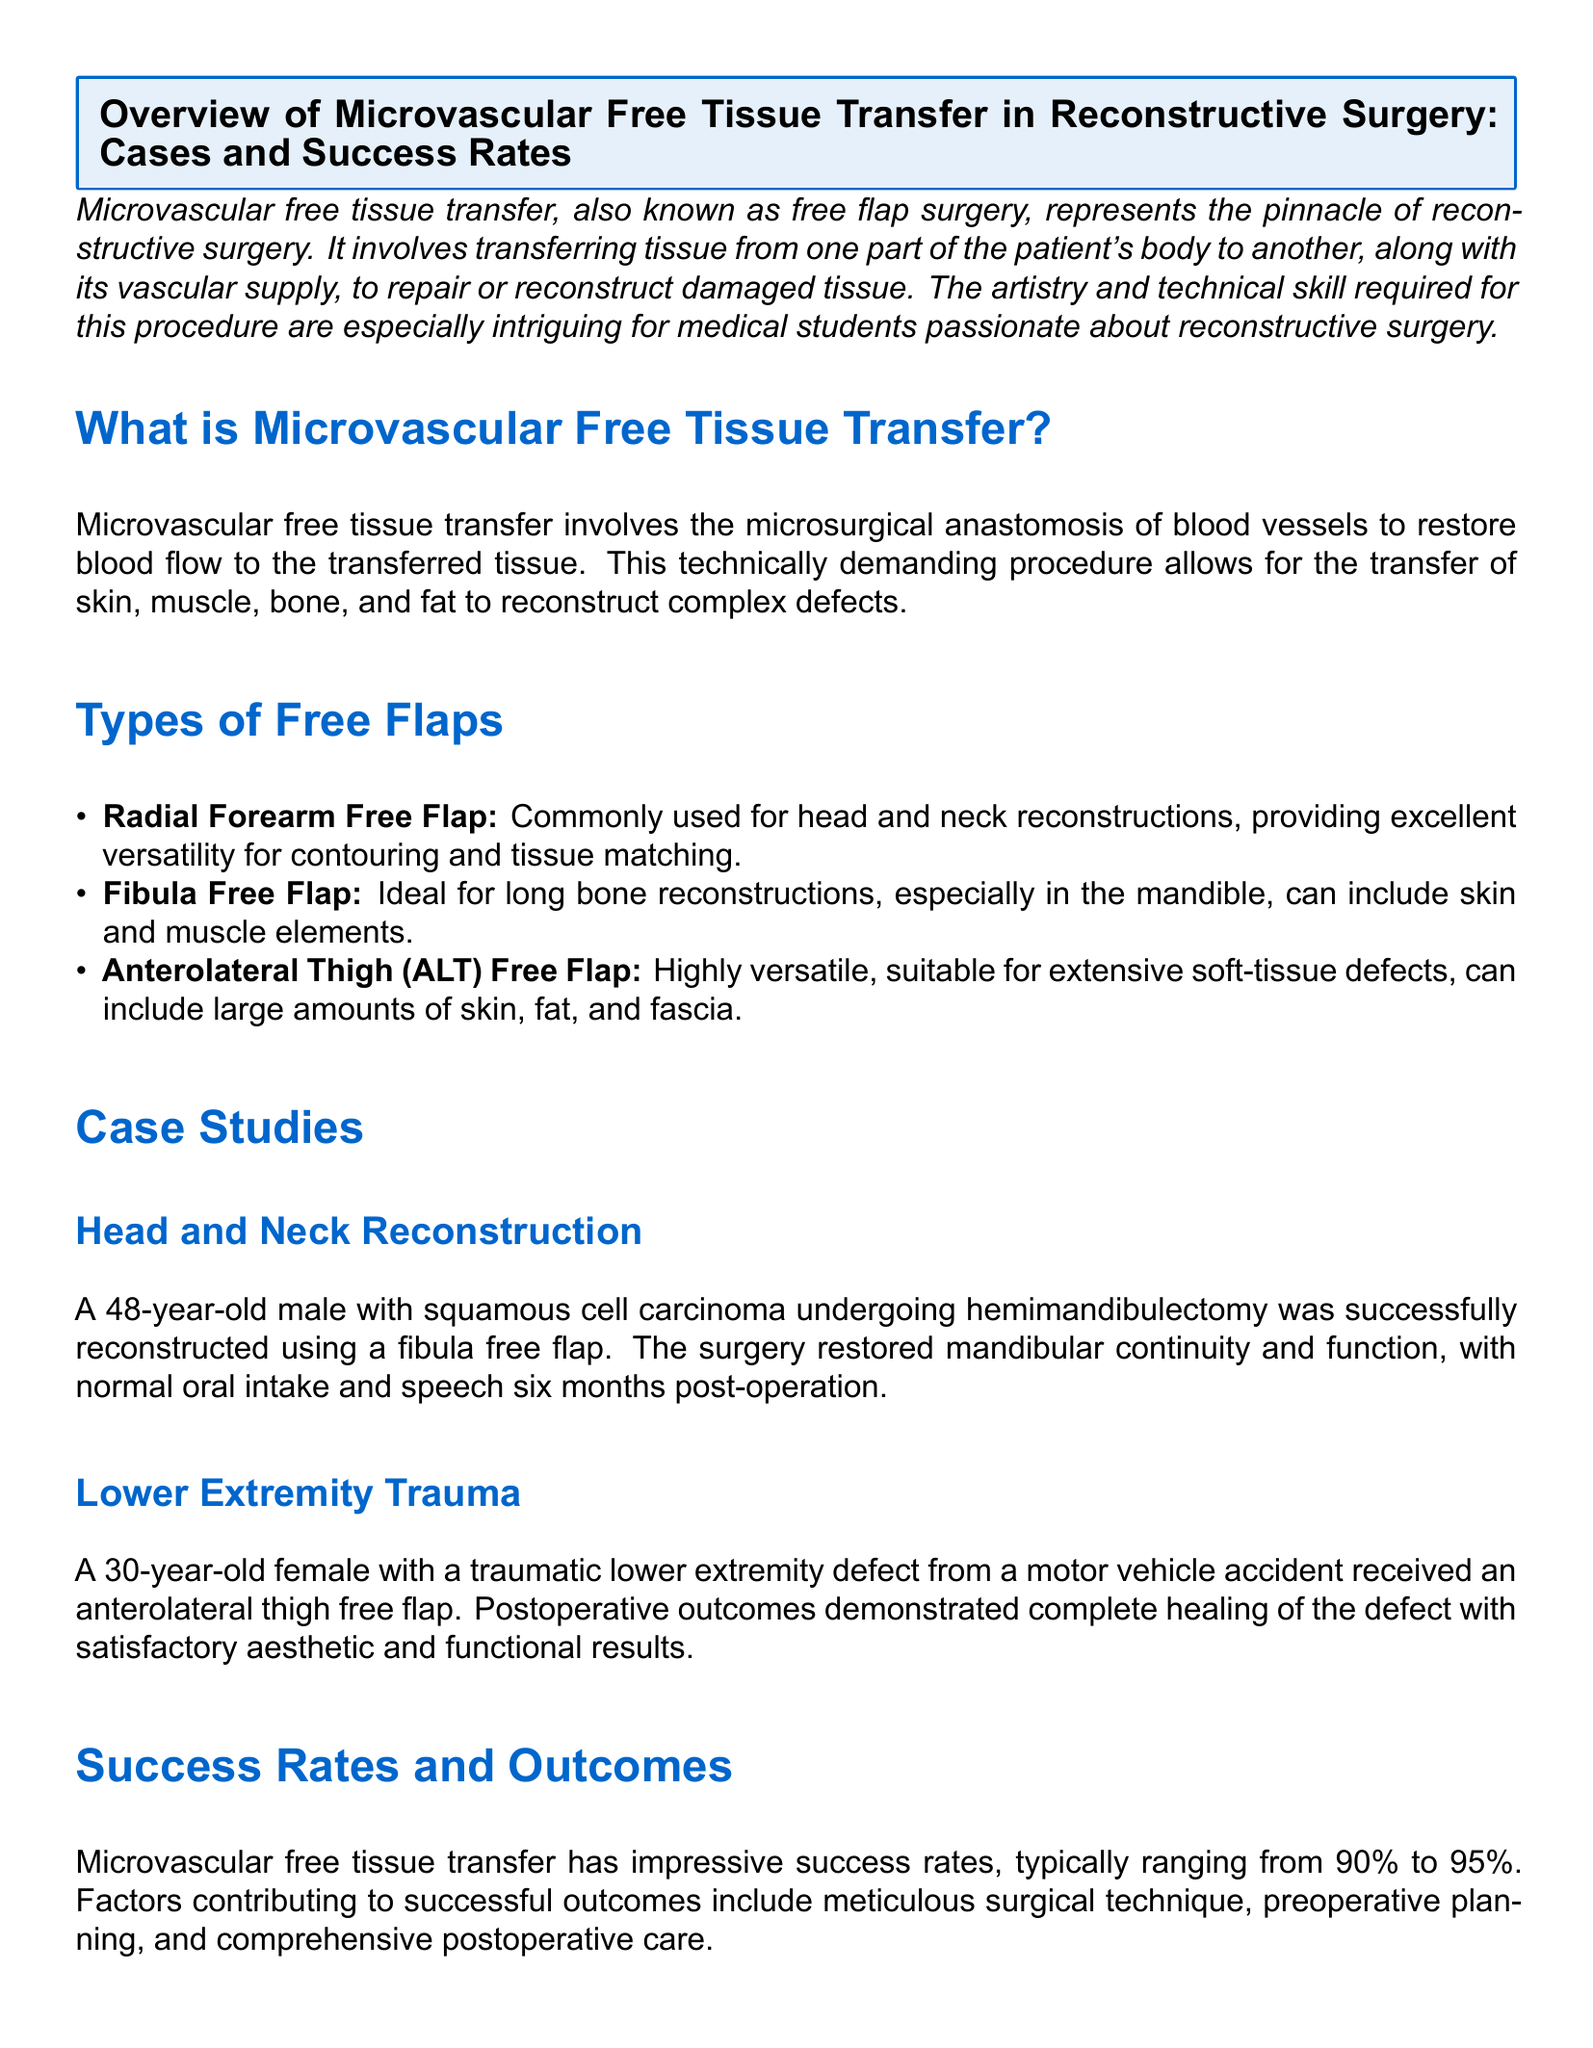What is microvascular free tissue transfer? Microvascular free tissue transfer involves the microsurgical anastomosis of blood vessels to restore blood flow to the transferred tissue.
Answer: Microsurgical anastomosis What is a common type of free flap for head and neck reconstruction? The document lists types of free flaps and specifies the radial forearm free flap for head and neck reconstructions.
Answer: Radial forearm free flap What was the age of the male patient in the head and neck reconstruction case study? The head and neck reconstruction case study mentions a 48-year-old male patient.
Answer: 48 What was the observed success rate range for microvascular free tissue transfer? Success rates are specifically stated as typically ranging from 90% to 95%.
Answer: 90% to 95% What complication risks are mentioned related to microvascular free tissue transfer? The document outlines potential risks such as flap failure, infection, and donor-site morbidity.
Answer: Flap failure, infection, donor-site morbidity How long after the operation did the male patient achieve normal oral intake and speech? The case study mentions that normal oral intake and speech were restored six months post-operation.
Answer: Six months What type of flap was used for the lower extremity trauma reconstruction? For the lower extremity trauma case, an anterolateral thigh free flap was utilized.
Answer: Anterolateral thigh free flap What factors contribute to successful outcomes in microvascular free tissue transfer? The document cites meticulous surgical technique, preoperative planning, and comprehensive postoperative care as contributing factors.
Answer: Surgical technique, preoperative planning, postoperative care What is the primary focus of the document? The document provides an overview of microvascular free tissue transfer, including case studies and success rates.
Answer: Overview of microvascular free tissue transfer 